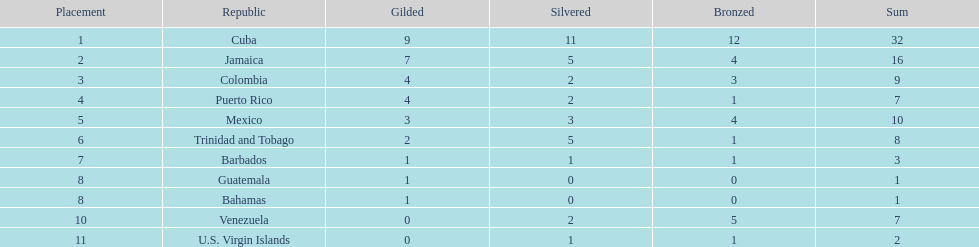Number of teams above 9 medals 3. 